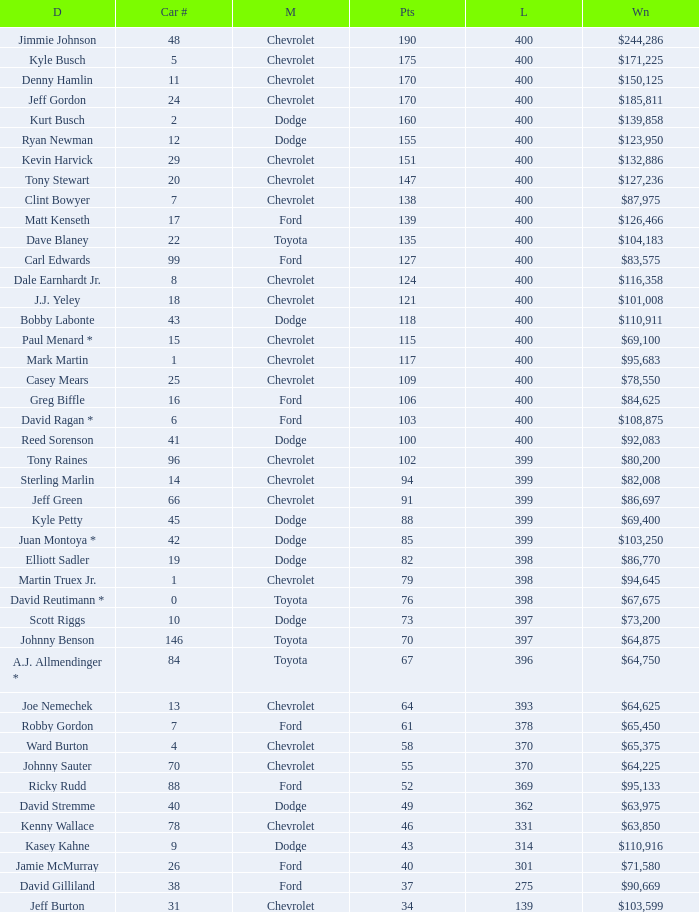What were the winnings for the Chevrolet with a number larger than 29 and scored 102 points? $80,200. 